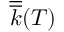Convert formula to latex. <formula><loc_0><loc_0><loc_500><loc_500>\overline { { \overline { k } } } ( T )</formula> 